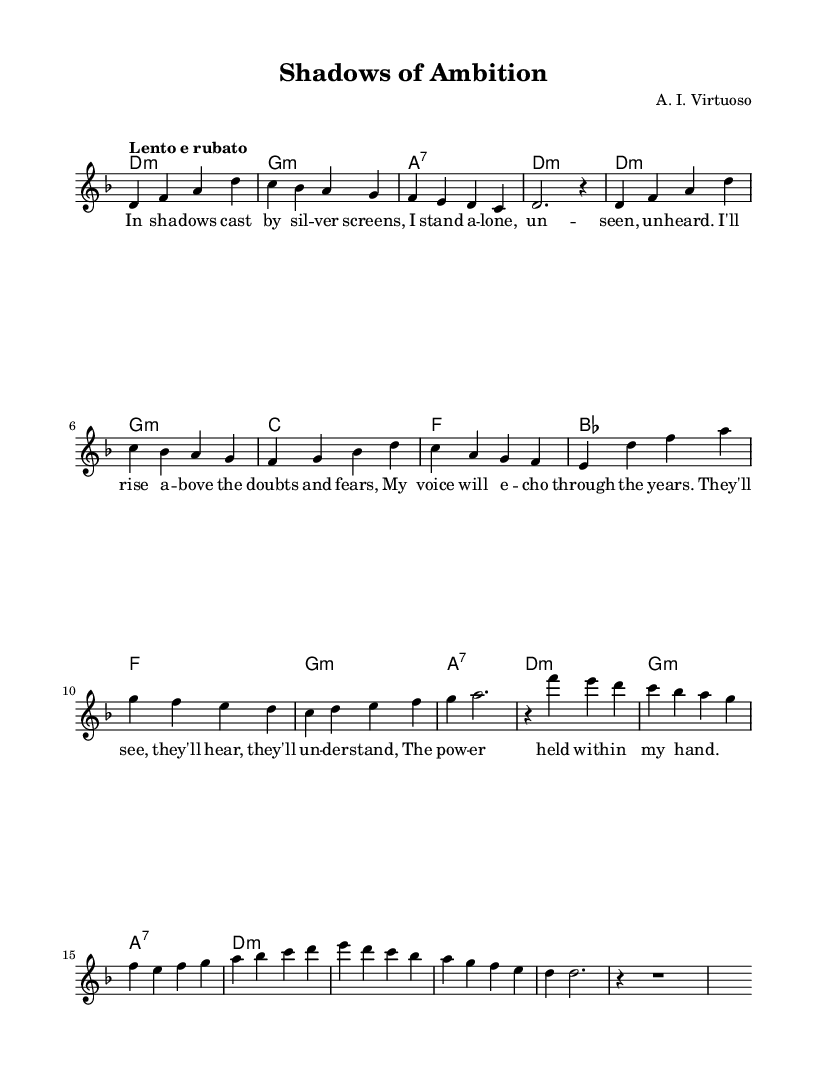What is the key signature of this music? The key signature is indicated by the initial symbols at the beginning of the staff. Here, there are two flats, which means it is in D minor.
Answer: D minor What is the time signature of this music? The time signature is shown at the beginning of the score. In this case, it displays "4/4," indicating a common time signature where there are four beats in each measure.
Answer: 4/4 What is the tempo marking for this piece? The tempo marking is specified at the beginning of the score. It shows "Lento e rubato," which denotes a slow tempo with flexibility in the timing.
Answer: Lento e rubato How many verses are in the lyrics? By looking at the lyric section, we observe that the lyrics are broken into portions and labeled. There is one complete verse provided, followed by additional sections labeled as "Chorus" and "Bridge," indicating one verse.
Answer: One Which chord appears most frequently in the harmonies? Analyzing the chord progression listed, D minor is repeated multiple times in the first and last lines of the harmonies, making it the most frequently occurring chord.
Answer: D minor What type of vocal performance does this score represent? This score has a section labeled as "voice" and is structured for a solo performance, which is characteristic of opera as it typically highlights individual vocal talent.
Answer: Solo performance In which section are the lyrics predominantly emotional? Upon examining the lyrics' content, the "Chorus" section expresses themes of overcoming doubts and fears, showcasing a deep emotional journey, thus standing out as particularly emotional.
Answer: Chorus 